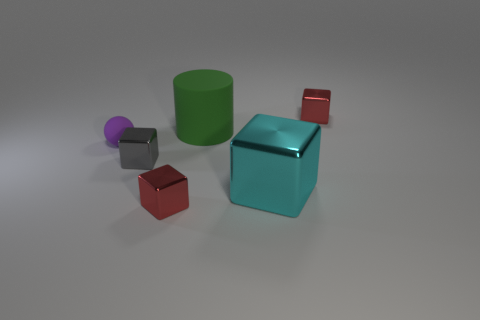Is the gray cube the same size as the cyan thing?
Keep it short and to the point. No. How many purple matte objects are the same size as the gray metal thing?
Give a very brief answer. 1. What size is the purple thing that is the same material as the large cylinder?
Make the answer very short. Small. Are there more red shiny blocks on the left side of the green cylinder than rubber cylinders in front of the gray thing?
Provide a short and direct response. Yes. Is the material of the large thing that is in front of the purple matte thing the same as the tiny gray object?
Keep it short and to the point. Yes. What is the color of the large thing that is the same shape as the small gray metallic object?
Make the answer very short. Cyan. The rubber thing behind the tiny rubber sphere has what shape?
Offer a very short reply. Cylinder. There is a large green cylinder; are there any red things to the right of it?
Your answer should be very brief. Yes. There is another large object that is made of the same material as the purple thing; what color is it?
Ensure brevity in your answer.  Green. There is a metal object that is behind the tiny matte ball; is its color the same as the small metallic thing in front of the gray metal thing?
Keep it short and to the point. Yes. 